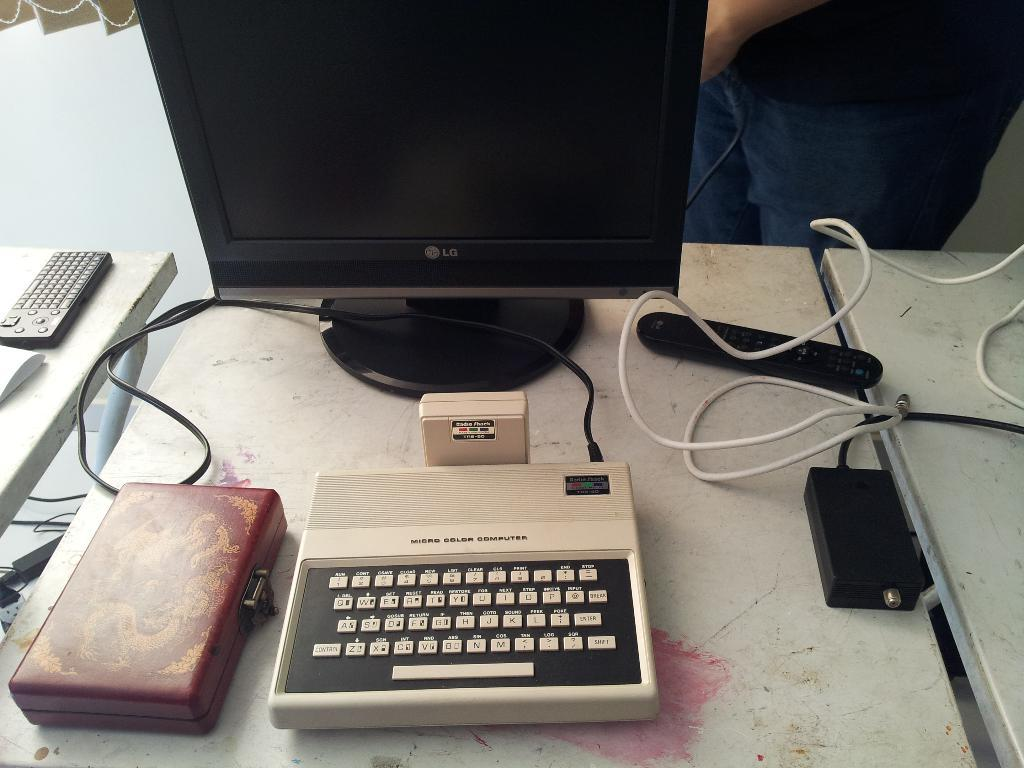Provide a one-sentence caption for the provided image. Wires attach an old Micro Color Computer to a new monitor. 